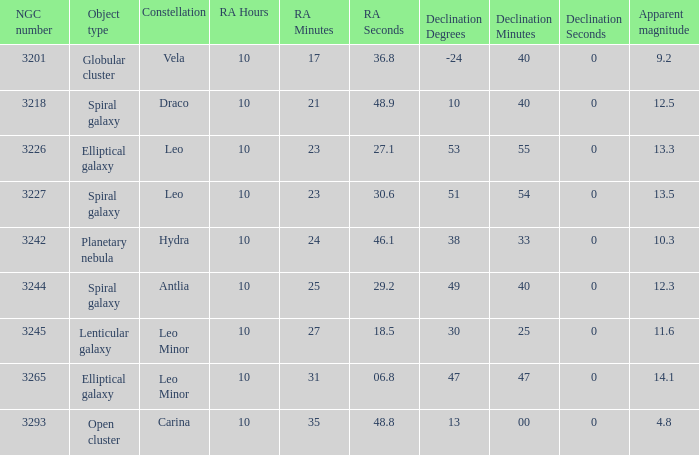What is the sum of NGC numbers for Constellation vela? 3201.0. 